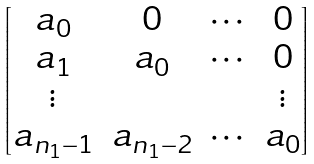Convert formula to latex. <formula><loc_0><loc_0><loc_500><loc_500>\begin{bmatrix} a _ { 0 } & 0 & \cdots & 0 \\ a _ { 1 } & a _ { 0 } & \cdots & 0 \\ \vdots & & & \vdots \\ a _ { n _ { 1 } - 1 } & a _ { n _ { 1 } - 2 } & \cdots & a _ { 0 } \end{bmatrix}</formula> 